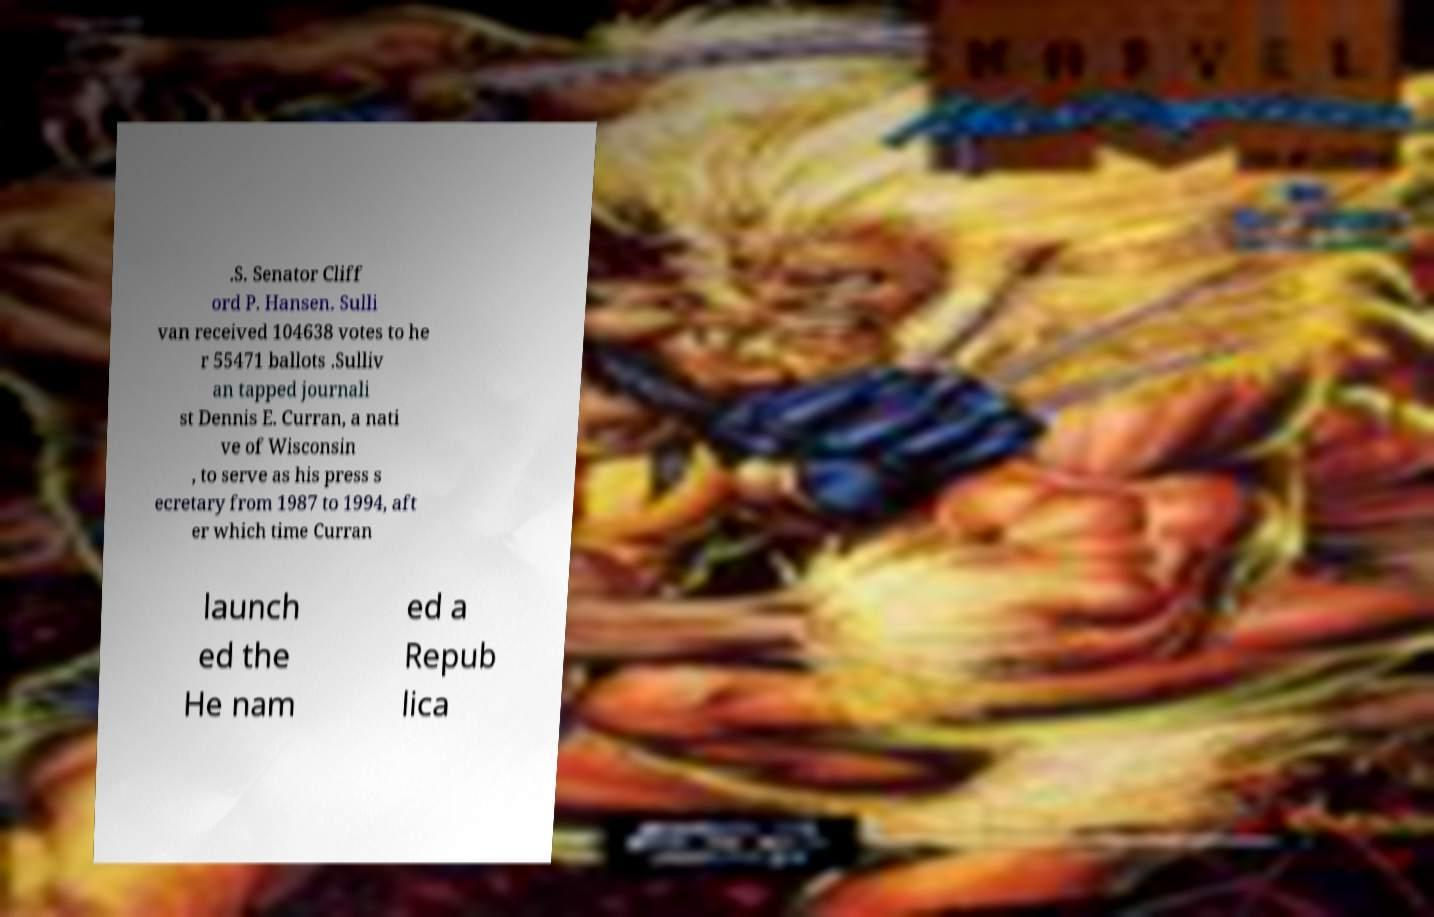Can you accurately transcribe the text from the provided image for me? .S. Senator Cliff ord P. Hansen. Sulli van received 104638 votes to he r 55471 ballots .Sulliv an tapped journali st Dennis E. Curran, a nati ve of Wisconsin , to serve as his press s ecretary from 1987 to 1994, aft er which time Curran launch ed the He nam ed a Repub lica 